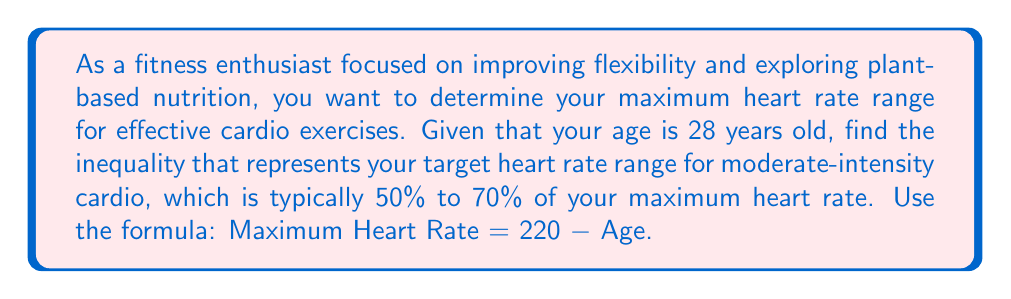Can you answer this question? Let's approach this step-by-step:

1) First, calculate the maximum heart rate:
   Maximum Heart Rate = 220 - Age
   $$ \text{Max HR} = 220 - 28 = 192 \text{ bpm} $$

2) For moderate-intensity cardio, we need 50% to 70% of the maximum heart rate:
   Lower bound: 50% of Max HR
   Upper bound: 70% of Max HR

3) Calculate these bounds:
   Lower bound: $0.50 \times 192 = 96 \text{ bpm}$
   Upper bound: $0.70 \times 192 = 134.4 \text{ bpm}$

4) Let $x$ represent the target heart rate in beats per minute (bpm).

5) The inequality representing the target heart rate range is:
   $$ 96 \leq x \leq 134.4 $$

This inequality means that for effective moderate-intensity cardio, your heart rate should be greater than or equal to 96 bpm and less than or equal to 134.4 bpm.
Answer: $96 \leq x \leq 134.4$ 